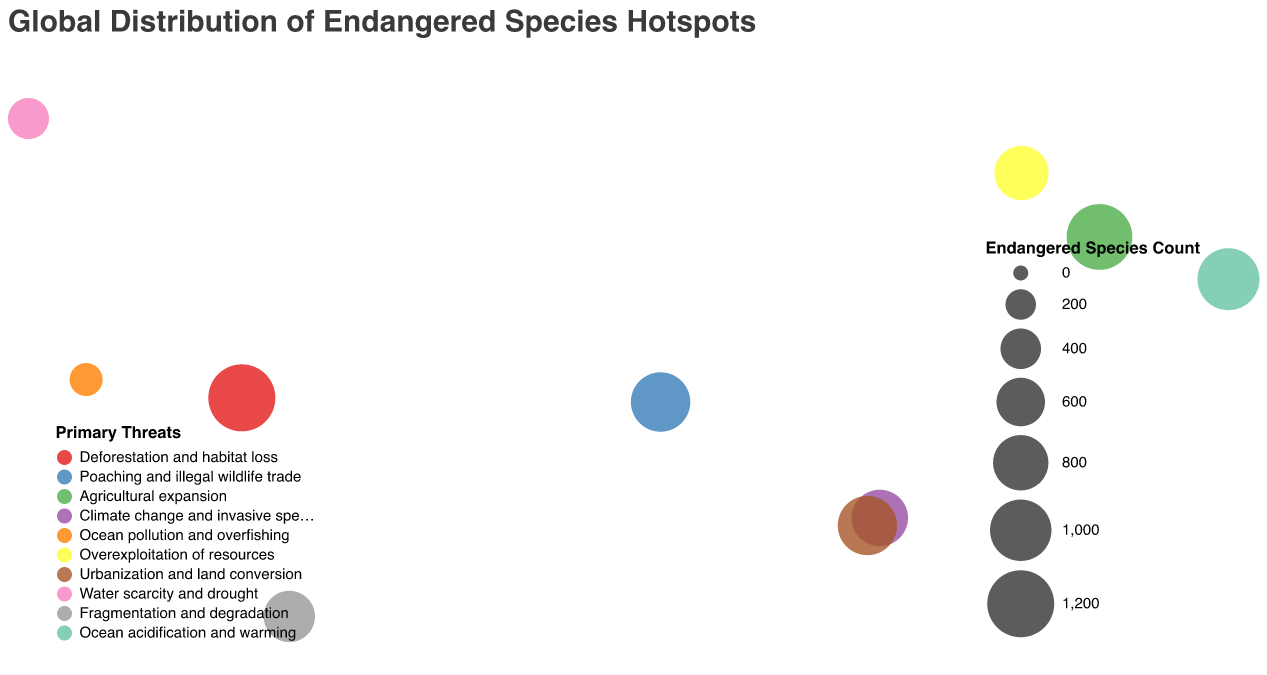What is the title of the figure? The title is usually displayed prominently at the top of the figure. In this case, the title is "Global Distribution of Endangered Species Hotspots".
Answer: Global Distribution of Endangered Species Hotspots Which region has the highest number of endangered species? By comparing the size of circles (which represents the count of endangered species), the Amazon Rainforest has the largest circle, indicating the highest number of endangered species.
Answer: Amazon Rainforest What is the primary threat to endangered species in Madagascar? By looking at the color-coded legend and matching it to the circle representing Madagascar, the primary threat is "Climate change and invasive species".
Answer: Climate change and invasive species How many regions have ocean-related threats to endangered species? Identify regions with threats like "Ocean pollution and overfishing" and "Ocean acidification and warming". These are the Galapagos Islands and Coral Triangle, respectively.
Answer: 2 Which region faces the threat of "Urbanization and land conversion"? The color legend indicates "Urbanization and land conversion" as represented by a color. The Sundaland region matches this color.
Answer: Sundaland Compare the number of endangered species between the North American Southwest and the Atlantic Forest. Which has more? By comparing the sizes of the circles for these two regions: Atlantic Forest has a larger circle, indicating more endangered species compared to North American Southwest.
Answer: Atlantic Forest What are the primary threats in the regions with the top three highest endangered species counts? The top three regions (Amazon Rainforest, Southeast Asian Rainforests, Coral Triangle) have the following threats: "Deforestation and habitat loss", "Agricultural expansion", and "Ocean acidification and warming".
Answer: Deforestation and habitat loss, Agricultural expansion, Ocean acidification and warming Where is the region with the threat of "Overexploitation of resources"? The legend color code for "Overexploitation of resources" points to Eastern Himalayas on the map.
Answer: Eastern Himalayas Sum the number of endangered species in the Congo Basin and Sundaland. Congo Basin has 932 and Sundaland has 928 endangered species. The sum is 932 + 928 = 1860.
Answer: 1860 Which region has the least number of endangered species among the listed regions? By identifying the smallest circle, the Galapagos Islands have the smallest circle which represents the least number of endangered species at 245.
Answer: Galapagos Islands 